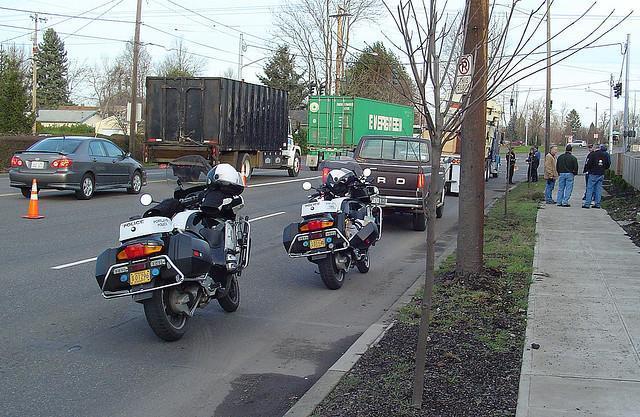How many motorcycles are there?
Give a very brief answer. 2. How many trucks are there?
Give a very brief answer. 3. 